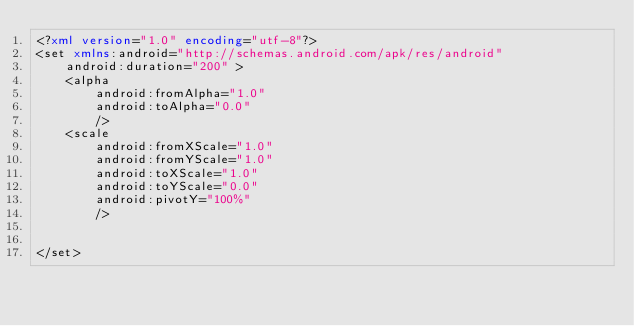Convert code to text. <code><loc_0><loc_0><loc_500><loc_500><_XML_><?xml version="1.0" encoding="utf-8"?>
<set xmlns:android="http://schemas.android.com/apk/res/android"
    android:duration="200" >
    <alpha
        android:fromAlpha="1.0"
        android:toAlpha="0.0"
        />
    <scale
        android:fromXScale="1.0"
        android:fromYScale="1.0"
        android:toXScale="1.0"
        android:toYScale="0.0"
        android:pivotY="100%"
        />


</set></code> 